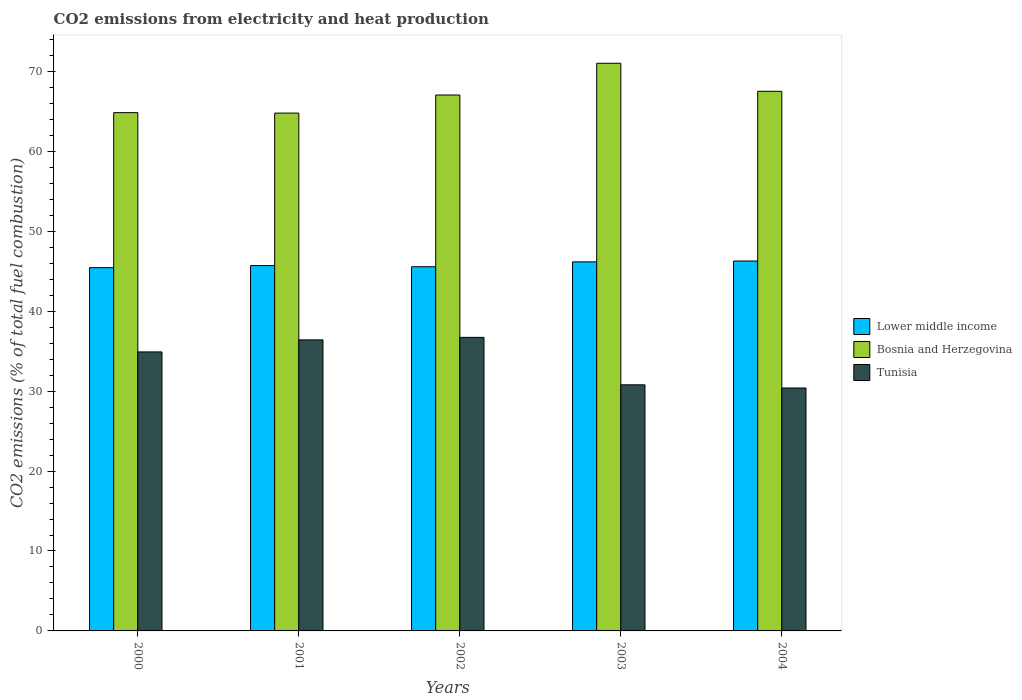How many different coloured bars are there?
Provide a short and direct response. 3. How many groups of bars are there?
Make the answer very short. 5. Are the number of bars on each tick of the X-axis equal?
Provide a short and direct response. Yes. How many bars are there on the 4th tick from the left?
Keep it short and to the point. 3. How many bars are there on the 2nd tick from the right?
Provide a short and direct response. 3. What is the label of the 5th group of bars from the left?
Your answer should be very brief. 2004. In how many cases, is the number of bars for a given year not equal to the number of legend labels?
Offer a terse response. 0. What is the amount of CO2 emitted in Lower middle income in 2000?
Offer a very short reply. 45.45. Across all years, what is the maximum amount of CO2 emitted in Bosnia and Herzegovina?
Provide a short and direct response. 71.02. Across all years, what is the minimum amount of CO2 emitted in Tunisia?
Your answer should be very brief. 30.39. In which year was the amount of CO2 emitted in Lower middle income maximum?
Keep it short and to the point. 2004. What is the total amount of CO2 emitted in Bosnia and Herzegovina in the graph?
Give a very brief answer. 335.21. What is the difference between the amount of CO2 emitted in Lower middle income in 2000 and that in 2002?
Provide a succinct answer. -0.12. What is the difference between the amount of CO2 emitted in Tunisia in 2003 and the amount of CO2 emitted in Lower middle income in 2004?
Offer a terse response. -15.49. What is the average amount of CO2 emitted in Tunisia per year?
Provide a short and direct response. 33.85. In the year 2004, what is the difference between the amount of CO2 emitted in Tunisia and amount of CO2 emitted in Bosnia and Herzegovina?
Your answer should be very brief. -37.12. In how many years, is the amount of CO2 emitted in Bosnia and Herzegovina greater than 16 %?
Ensure brevity in your answer.  5. What is the ratio of the amount of CO2 emitted in Tunisia in 2000 to that in 2003?
Your response must be concise. 1.13. Is the amount of CO2 emitted in Bosnia and Herzegovina in 2003 less than that in 2004?
Your answer should be compact. No. Is the difference between the amount of CO2 emitted in Tunisia in 2000 and 2001 greater than the difference between the amount of CO2 emitted in Bosnia and Herzegovina in 2000 and 2001?
Make the answer very short. No. What is the difference between the highest and the second highest amount of CO2 emitted in Tunisia?
Offer a terse response. 0.32. What is the difference between the highest and the lowest amount of CO2 emitted in Tunisia?
Offer a terse response. 6.33. In how many years, is the amount of CO2 emitted in Lower middle income greater than the average amount of CO2 emitted in Lower middle income taken over all years?
Provide a succinct answer. 2. What does the 3rd bar from the left in 2000 represents?
Make the answer very short. Tunisia. What does the 2nd bar from the right in 2001 represents?
Your answer should be very brief. Bosnia and Herzegovina. Is it the case that in every year, the sum of the amount of CO2 emitted in Lower middle income and amount of CO2 emitted in Bosnia and Herzegovina is greater than the amount of CO2 emitted in Tunisia?
Give a very brief answer. Yes. What is the difference between two consecutive major ticks on the Y-axis?
Your answer should be very brief. 10. Are the values on the major ticks of Y-axis written in scientific E-notation?
Make the answer very short. No. Where does the legend appear in the graph?
Provide a succinct answer. Center right. How many legend labels are there?
Give a very brief answer. 3. How are the legend labels stacked?
Your response must be concise. Vertical. What is the title of the graph?
Provide a short and direct response. CO2 emissions from electricity and heat production. Does "Middle East & North Africa (developing only)" appear as one of the legend labels in the graph?
Your answer should be compact. No. What is the label or title of the Y-axis?
Give a very brief answer. CO2 emissions (% of total fuel combustion). What is the CO2 emissions (% of total fuel combustion) of Lower middle income in 2000?
Your response must be concise. 45.45. What is the CO2 emissions (% of total fuel combustion) of Bosnia and Herzegovina in 2000?
Offer a very short reply. 64.84. What is the CO2 emissions (% of total fuel combustion) of Tunisia in 2000?
Give a very brief answer. 34.91. What is the CO2 emissions (% of total fuel combustion) in Lower middle income in 2001?
Your answer should be very brief. 45.71. What is the CO2 emissions (% of total fuel combustion) in Bosnia and Herzegovina in 2001?
Your response must be concise. 64.79. What is the CO2 emissions (% of total fuel combustion) in Tunisia in 2001?
Your answer should be compact. 36.41. What is the CO2 emissions (% of total fuel combustion) of Lower middle income in 2002?
Ensure brevity in your answer.  45.56. What is the CO2 emissions (% of total fuel combustion) of Bosnia and Herzegovina in 2002?
Provide a short and direct response. 67.05. What is the CO2 emissions (% of total fuel combustion) of Tunisia in 2002?
Your answer should be compact. 36.73. What is the CO2 emissions (% of total fuel combustion) of Lower middle income in 2003?
Provide a succinct answer. 46.17. What is the CO2 emissions (% of total fuel combustion) in Bosnia and Herzegovina in 2003?
Make the answer very short. 71.02. What is the CO2 emissions (% of total fuel combustion) in Tunisia in 2003?
Your answer should be very brief. 30.79. What is the CO2 emissions (% of total fuel combustion) in Lower middle income in 2004?
Give a very brief answer. 46.28. What is the CO2 emissions (% of total fuel combustion) in Bosnia and Herzegovina in 2004?
Provide a short and direct response. 67.51. What is the CO2 emissions (% of total fuel combustion) in Tunisia in 2004?
Give a very brief answer. 30.39. Across all years, what is the maximum CO2 emissions (% of total fuel combustion) in Lower middle income?
Give a very brief answer. 46.28. Across all years, what is the maximum CO2 emissions (% of total fuel combustion) of Bosnia and Herzegovina?
Give a very brief answer. 71.02. Across all years, what is the maximum CO2 emissions (% of total fuel combustion) of Tunisia?
Ensure brevity in your answer.  36.73. Across all years, what is the minimum CO2 emissions (% of total fuel combustion) in Lower middle income?
Give a very brief answer. 45.45. Across all years, what is the minimum CO2 emissions (% of total fuel combustion) in Bosnia and Herzegovina?
Your answer should be compact. 64.79. Across all years, what is the minimum CO2 emissions (% of total fuel combustion) in Tunisia?
Give a very brief answer. 30.39. What is the total CO2 emissions (% of total fuel combustion) of Lower middle income in the graph?
Keep it short and to the point. 229.17. What is the total CO2 emissions (% of total fuel combustion) in Bosnia and Herzegovina in the graph?
Your answer should be compact. 335.21. What is the total CO2 emissions (% of total fuel combustion) of Tunisia in the graph?
Offer a terse response. 169.23. What is the difference between the CO2 emissions (% of total fuel combustion) of Lower middle income in 2000 and that in 2001?
Make the answer very short. -0.26. What is the difference between the CO2 emissions (% of total fuel combustion) in Bosnia and Herzegovina in 2000 and that in 2001?
Offer a terse response. 0.06. What is the difference between the CO2 emissions (% of total fuel combustion) in Tunisia in 2000 and that in 2001?
Your answer should be very brief. -1.51. What is the difference between the CO2 emissions (% of total fuel combustion) in Lower middle income in 2000 and that in 2002?
Offer a terse response. -0.12. What is the difference between the CO2 emissions (% of total fuel combustion) in Bosnia and Herzegovina in 2000 and that in 2002?
Your answer should be compact. -2.21. What is the difference between the CO2 emissions (% of total fuel combustion) in Tunisia in 2000 and that in 2002?
Ensure brevity in your answer.  -1.82. What is the difference between the CO2 emissions (% of total fuel combustion) in Lower middle income in 2000 and that in 2003?
Give a very brief answer. -0.72. What is the difference between the CO2 emissions (% of total fuel combustion) in Bosnia and Herzegovina in 2000 and that in 2003?
Give a very brief answer. -6.18. What is the difference between the CO2 emissions (% of total fuel combustion) of Tunisia in 2000 and that in 2003?
Provide a short and direct response. 4.12. What is the difference between the CO2 emissions (% of total fuel combustion) in Lower middle income in 2000 and that in 2004?
Keep it short and to the point. -0.83. What is the difference between the CO2 emissions (% of total fuel combustion) in Bosnia and Herzegovina in 2000 and that in 2004?
Your answer should be very brief. -2.67. What is the difference between the CO2 emissions (% of total fuel combustion) of Tunisia in 2000 and that in 2004?
Ensure brevity in your answer.  4.51. What is the difference between the CO2 emissions (% of total fuel combustion) of Lower middle income in 2001 and that in 2002?
Your response must be concise. 0.14. What is the difference between the CO2 emissions (% of total fuel combustion) in Bosnia and Herzegovina in 2001 and that in 2002?
Provide a short and direct response. -2.26. What is the difference between the CO2 emissions (% of total fuel combustion) of Tunisia in 2001 and that in 2002?
Offer a terse response. -0.32. What is the difference between the CO2 emissions (% of total fuel combustion) of Lower middle income in 2001 and that in 2003?
Provide a succinct answer. -0.46. What is the difference between the CO2 emissions (% of total fuel combustion) in Bosnia and Herzegovina in 2001 and that in 2003?
Give a very brief answer. -6.23. What is the difference between the CO2 emissions (% of total fuel combustion) in Tunisia in 2001 and that in 2003?
Keep it short and to the point. 5.62. What is the difference between the CO2 emissions (% of total fuel combustion) in Lower middle income in 2001 and that in 2004?
Your answer should be very brief. -0.57. What is the difference between the CO2 emissions (% of total fuel combustion) in Bosnia and Herzegovina in 2001 and that in 2004?
Offer a very short reply. -2.73. What is the difference between the CO2 emissions (% of total fuel combustion) of Tunisia in 2001 and that in 2004?
Give a very brief answer. 6.02. What is the difference between the CO2 emissions (% of total fuel combustion) of Lower middle income in 2002 and that in 2003?
Your answer should be very brief. -0.61. What is the difference between the CO2 emissions (% of total fuel combustion) of Bosnia and Herzegovina in 2002 and that in 2003?
Offer a very short reply. -3.97. What is the difference between the CO2 emissions (% of total fuel combustion) of Tunisia in 2002 and that in 2003?
Your response must be concise. 5.94. What is the difference between the CO2 emissions (% of total fuel combustion) in Lower middle income in 2002 and that in 2004?
Make the answer very short. -0.72. What is the difference between the CO2 emissions (% of total fuel combustion) of Bosnia and Herzegovina in 2002 and that in 2004?
Ensure brevity in your answer.  -0.47. What is the difference between the CO2 emissions (% of total fuel combustion) of Tunisia in 2002 and that in 2004?
Give a very brief answer. 6.33. What is the difference between the CO2 emissions (% of total fuel combustion) in Lower middle income in 2003 and that in 2004?
Give a very brief answer. -0.11. What is the difference between the CO2 emissions (% of total fuel combustion) of Bosnia and Herzegovina in 2003 and that in 2004?
Your answer should be compact. 3.51. What is the difference between the CO2 emissions (% of total fuel combustion) in Tunisia in 2003 and that in 2004?
Ensure brevity in your answer.  0.4. What is the difference between the CO2 emissions (% of total fuel combustion) in Lower middle income in 2000 and the CO2 emissions (% of total fuel combustion) in Bosnia and Herzegovina in 2001?
Your answer should be very brief. -19.34. What is the difference between the CO2 emissions (% of total fuel combustion) in Lower middle income in 2000 and the CO2 emissions (% of total fuel combustion) in Tunisia in 2001?
Ensure brevity in your answer.  9.04. What is the difference between the CO2 emissions (% of total fuel combustion) of Bosnia and Herzegovina in 2000 and the CO2 emissions (% of total fuel combustion) of Tunisia in 2001?
Provide a short and direct response. 28.43. What is the difference between the CO2 emissions (% of total fuel combustion) of Lower middle income in 2000 and the CO2 emissions (% of total fuel combustion) of Bosnia and Herzegovina in 2002?
Offer a terse response. -21.6. What is the difference between the CO2 emissions (% of total fuel combustion) of Lower middle income in 2000 and the CO2 emissions (% of total fuel combustion) of Tunisia in 2002?
Offer a terse response. 8.72. What is the difference between the CO2 emissions (% of total fuel combustion) in Bosnia and Herzegovina in 2000 and the CO2 emissions (% of total fuel combustion) in Tunisia in 2002?
Ensure brevity in your answer.  28.11. What is the difference between the CO2 emissions (% of total fuel combustion) of Lower middle income in 2000 and the CO2 emissions (% of total fuel combustion) of Bosnia and Herzegovina in 2003?
Your answer should be compact. -25.57. What is the difference between the CO2 emissions (% of total fuel combustion) in Lower middle income in 2000 and the CO2 emissions (% of total fuel combustion) in Tunisia in 2003?
Your answer should be very brief. 14.66. What is the difference between the CO2 emissions (% of total fuel combustion) in Bosnia and Herzegovina in 2000 and the CO2 emissions (% of total fuel combustion) in Tunisia in 2003?
Make the answer very short. 34.05. What is the difference between the CO2 emissions (% of total fuel combustion) of Lower middle income in 2000 and the CO2 emissions (% of total fuel combustion) of Bosnia and Herzegovina in 2004?
Make the answer very short. -22.07. What is the difference between the CO2 emissions (% of total fuel combustion) of Lower middle income in 2000 and the CO2 emissions (% of total fuel combustion) of Tunisia in 2004?
Provide a short and direct response. 15.05. What is the difference between the CO2 emissions (% of total fuel combustion) in Bosnia and Herzegovina in 2000 and the CO2 emissions (% of total fuel combustion) in Tunisia in 2004?
Your response must be concise. 34.45. What is the difference between the CO2 emissions (% of total fuel combustion) of Lower middle income in 2001 and the CO2 emissions (% of total fuel combustion) of Bosnia and Herzegovina in 2002?
Your answer should be very brief. -21.34. What is the difference between the CO2 emissions (% of total fuel combustion) of Lower middle income in 2001 and the CO2 emissions (% of total fuel combustion) of Tunisia in 2002?
Offer a terse response. 8.98. What is the difference between the CO2 emissions (% of total fuel combustion) of Bosnia and Herzegovina in 2001 and the CO2 emissions (% of total fuel combustion) of Tunisia in 2002?
Provide a short and direct response. 28.06. What is the difference between the CO2 emissions (% of total fuel combustion) of Lower middle income in 2001 and the CO2 emissions (% of total fuel combustion) of Bosnia and Herzegovina in 2003?
Provide a succinct answer. -25.31. What is the difference between the CO2 emissions (% of total fuel combustion) of Lower middle income in 2001 and the CO2 emissions (% of total fuel combustion) of Tunisia in 2003?
Ensure brevity in your answer.  14.92. What is the difference between the CO2 emissions (% of total fuel combustion) of Bosnia and Herzegovina in 2001 and the CO2 emissions (% of total fuel combustion) of Tunisia in 2003?
Give a very brief answer. 34. What is the difference between the CO2 emissions (% of total fuel combustion) of Lower middle income in 2001 and the CO2 emissions (% of total fuel combustion) of Bosnia and Herzegovina in 2004?
Offer a very short reply. -21.81. What is the difference between the CO2 emissions (% of total fuel combustion) in Lower middle income in 2001 and the CO2 emissions (% of total fuel combustion) in Tunisia in 2004?
Your answer should be very brief. 15.31. What is the difference between the CO2 emissions (% of total fuel combustion) of Bosnia and Herzegovina in 2001 and the CO2 emissions (% of total fuel combustion) of Tunisia in 2004?
Provide a succinct answer. 34.39. What is the difference between the CO2 emissions (% of total fuel combustion) in Lower middle income in 2002 and the CO2 emissions (% of total fuel combustion) in Bosnia and Herzegovina in 2003?
Offer a very short reply. -25.46. What is the difference between the CO2 emissions (% of total fuel combustion) in Lower middle income in 2002 and the CO2 emissions (% of total fuel combustion) in Tunisia in 2003?
Ensure brevity in your answer.  14.77. What is the difference between the CO2 emissions (% of total fuel combustion) of Bosnia and Herzegovina in 2002 and the CO2 emissions (% of total fuel combustion) of Tunisia in 2003?
Ensure brevity in your answer.  36.26. What is the difference between the CO2 emissions (% of total fuel combustion) of Lower middle income in 2002 and the CO2 emissions (% of total fuel combustion) of Bosnia and Herzegovina in 2004?
Ensure brevity in your answer.  -21.95. What is the difference between the CO2 emissions (% of total fuel combustion) of Lower middle income in 2002 and the CO2 emissions (% of total fuel combustion) of Tunisia in 2004?
Give a very brief answer. 15.17. What is the difference between the CO2 emissions (% of total fuel combustion) in Bosnia and Herzegovina in 2002 and the CO2 emissions (% of total fuel combustion) in Tunisia in 2004?
Give a very brief answer. 36.66. What is the difference between the CO2 emissions (% of total fuel combustion) in Lower middle income in 2003 and the CO2 emissions (% of total fuel combustion) in Bosnia and Herzegovina in 2004?
Your answer should be very brief. -21.34. What is the difference between the CO2 emissions (% of total fuel combustion) in Lower middle income in 2003 and the CO2 emissions (% of total fuel combustion) in Tunisia in 2004?
Provide a succinct answer. 15.78. What is the difference between the CO2 emissions (% of total fuel combustion) of Bosnia and Herzegovina in 2003 and the CO2 emissions (% of total fuel combustion) of Tunisia in 2004?
Your answer should be very brief. 40.63. What is the average CO2 emissions (% of total fuel combustion) in Lower middle income per year?
Keep it short and to the point. 45.83. What is the average CO2 emissions (% of total fuel combustion) of Bosnia and Herzegovina per year?
Your response must be concise. 67.04. What is the average CO2 emissions (% of total fuel combustion) of Tunisia per year?
Provide a short and direct response. 33.85. In the year 2000, what is the difference between the CO2 emissions (% of total fuel combustion) of Lower middle income and CO2 emissions (% of total fuel combustion) of Bosnia and Herzegovina?
Offer a very short reply. -19.39. In the year 2000, what is the difference between the CO2 emissions (% of total fuel combustion) in Lower middle income and CO2 emissions (% of total fuel combustion) in Tunisia?
Provide a succinct answer. 10.54. In the year 2000, what is the difference between the CO2 emissions (% of total fuel combustion) of Bosnia and Herzegovina and CO2 emissions (% of total fuel combustion) of Tunisia?
Offer a terse response. 29.94. In the year 2001, what is the difference between the CO2 emissions (% of total fuel combustion) of Lower middle income and CO2 emissions (% of total fuel combustion) of Bosnia and Herzegovina?
Offer a very short reply. -19.08. In the year 2001, what is the difference between the CO2 emissions (% of total fuel combustion) in Lower middle income and CO2 emissions (% of total fuel combustion) in Tunisia?
Your answer should be compact. 9.3. In the year 2001, what is the difference between the CO2 emissions (% of total fuel combustion) of Bosnia and Herzegovina and CO2 emissions (% of total fuel combustion) of Tunisia?
Offer a very short reply. 28.37. In the year 2002, what is the difference between the CO2 emissions (% of total fuel combustion) of Lower middle income and CO2 emissions (% of total fuel combustion) of Bosnia and Herzegovina?
Provide a short and direct response. -21.49. In the year 2002, what is the difference between the CO2 emissions (% of total fuel combustion) of Lower middle income and CO2 emissions (% of total fuel combustion) of Tunisia?
Give a very brief answer. 8.84. In the year 2002, what is the difference between the CO2 emissions (% of total fuel combustion) in Bosnia and Herzegovina and CO2 emissions (% of total fuel combustion) in Tunisia?
Keep it short and to the point. 30.32. In the year 2003, what is the difference between the CO2 emissions (% of total fuel combustion) in Lower middle income and CO2 emissions (% of total fuel combustion) in Bosnia and Herzegovina?
Give a very brief answer. -24.85. In the year 2003, what is the difference between the CO2 emissions (% of total fuel combustion) of Lower middle income and CO2 emissions (% of total fuel combustion) of Tunisia?
Ensure brevity in your answer.  15.38. In the year 2003, what is the difference between the CO2 emissions (% of total fuel combustion) in Bosnia and Herzegovina and CO2 emissions (% of total fuel combustion) in Tunisia?
Your response must be concise. 40.23. In the year 2004, what is the difference between the CO2 emissions (% of total fuel combustion) of Lower middle income and CO2 emissions (% of total fuel combustion) of Bosnia and Herzegovina?
Offer a very short reply. -21.23. In the year 2004, what is the difference between the CO2 emissions (% of total fuel combustion) in Lower middle income and CO2 emissions (% of total fuel combustion) in Tunisia?
Ensure brevity in your answer.  15.89. In the year 2004, what is the difference between the CO2 emissions (% of total fuel combustion) in Bosnia and Herzegovina and CO2 emissions (% of total fuel combustion) in Tunisia?
Provide a succinct answer. 37.12. What is the ratio of the CO2 emissions (% of total fuel combustion) in Tunisia in 2000 to that in 2001?
Your answer should be very brief. 0.96. What is the ratio of the CO2 emissions (% of total fuel combustion) in Lower middle income in 2000 to that in 2002?
Give a very brief answer. 1. What is the ratio of the CO2 emissions (% of total fuel combustion) in Bosnia and Herzegovina in 2000 to that in 2002?
Keep it short and to the point. 0.97. What is the ratio of the CO2 emissions (% of total fuel combustion) of Tunisia in 2000 to that in 2002?
Keep it short and to the point. 0.95. What is the ratio of the CO2 emissions (% of total fuel combustion) of Lower middle income in 2000 to that in 2003?
Your answer should be compact. 0.98. What is the ratio of the CO2 emissions (% of total fuel combustion) in Tunisia in 2000 to that in 2003?
Provide a succinct answer. 1.13. What is the ratio of the CO2 emissions (% of total fuel combustion) in Lower middle income in 2000 to that in 2004?
Your answer should be compact. 0.98. What is the ratio of the CO2 emissions (% of total fuel combustion) in Bosnia and Herzegovina in 2000 to that in 2004?
Your answer should be compact. 0.96. What is the ratio of the CO2 emissions (% of total fuel combustion) of Tunisia in 2000 to that in 2004?
Make the answer very short. 1.15. What is the ratio of the CO2 emissions (% of total fuel combustion) in Lower middle income in 2001 to that in 2002?
Provide a succinct answer. 1. What is the ratio of the CO2 emissions (% of total fuel combustion) in Bosnia and Herzegovina in 2001 to that in 2002?
Your response must be concise. 0.97. What is the ratio of the CO2 emissions (% of total fuel combustion) of Tunisia in 2001 to that in 2002?
Your response must be concise. 0.99. What is the ratio of the CO2 emissions (% of total fuel combustion) in Lower middle income in 2001 to that in 2003?
Make the answer very short. 0.99. What is the ratio of the CO2 emissions (% of total fuel combustion) of Bosnia and Herzegovina in 2001 to that in 2003?
Your response must be concise. 0.91. What is the ratio of the CO2 emissions (% of total fuel combustion) of Tunisia in 2001 to that in 2003?
Give a very brief answer. 1.18. What is the ratio of the CO2 emissions (% of total fuel combustion) in Lower middle income in 2001 to that in 2004?
Offer a very short reply. 0.99. What is the ratio of the CO2 emissions (% of total fuel combustion) of Bosnia and Herzegovina in 2001 to that in 2004?
Your answer should be compact. 0.96. What is the ratio of the CO2 emissions (% of total fuel combustion) of Tunisia in 2001 to that in 2004?
Ensure brevity in your answer.  1.2. What is the ratio of the CO2 emissions (% of total fuel combustion) in Bosnia and Herzegovina in 2002 to that in 2003?
Give a very brief answer. 0.94. What is the ratio of the CO2 emissions (% of total fuel combustion) in Tunisia in 2002 to that in 2003?
Provide a succinct answer. 1.19. What is the ratio of the CO2 emissions (% of total fuel combustion) of Lower middle income in 2002 to that in 2004?
Make the answer very short. 0.98. What is the ratio of the CO2 emissions (% of total fuel combustion) in Bosnia and Herzegovina in 2002 to that in 2004?
Provide a succinct answer. 0.99. What is the ratio of the CO2 emissions (% of total fuel combustion) in Tunisia in 2002 to that in 2004?
Give a very brief answer. 1.21. What is the ratio of the CO2 emissions (% of total fuel combustion) in Bosnia and Herzegovina in 2003 to that in 2004?
Make the answer very short. 1.05. What is the ratio of the CO2 emissions (% of total fuel combustion) in Tunisia in 2003 to that in 2004?
Make the answer very short. 1.01. What is the difference between the highest and the second highest CO2 emissions (% of total fuel combustion) of Lower middle income?
Keep it short and to the point. 0.11. What is the difference between the highest and the second highest CO2 emissions (% of total fuel combustion) of Bosnia and Herzegovina?
Give a very brief answer. 3.51. What is the difference between the highest and the second highest CO2 emissions (% of total fuel combustion) of Tunisia?
Offer a terse response. 0.32. What is the difference between the highest and the lowest CO2 emissions (% of total fuel combustion) of Lower middle income?
Your answer should be very brief. 0.83. What is the difference between the highest and the lowest CO2 emissions (% of total fuel combustion) of Bosnia and Herzegovina?
Ensure brevity in your answer.  6.23. What is the difference between the highest and the lowest CO2 emissions (% of total fuel combustion) in Tunisia?
Make the answer very short. 6.33. 